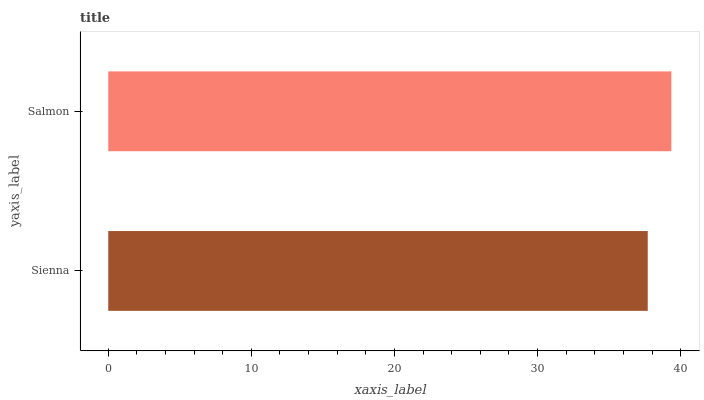Is Sienna the minimum?
Answer yes or no. Yes. Is Salmon the maximum?
Answer yes or no. Yes. Is Salmon the minimum?
Answer yes or no. No. Is Salmon greater than Sienna?
Answer yes or no. Yes. Is Sienna less than Salmon?
Answer yes or no. Yes. Is Sienna greater than Salmon?
Answer yes or no. No. Is Salmon less than Sienna?
Answer yes or no. No. Is Salmon the high median?
Answer yes or no. Yes. Is Sienna the low median?
Answer yes or no. Yes. Is Sienna the high median?
Answer yes or no. No. Is Salmon the low median?
Answer yes or no. No. 